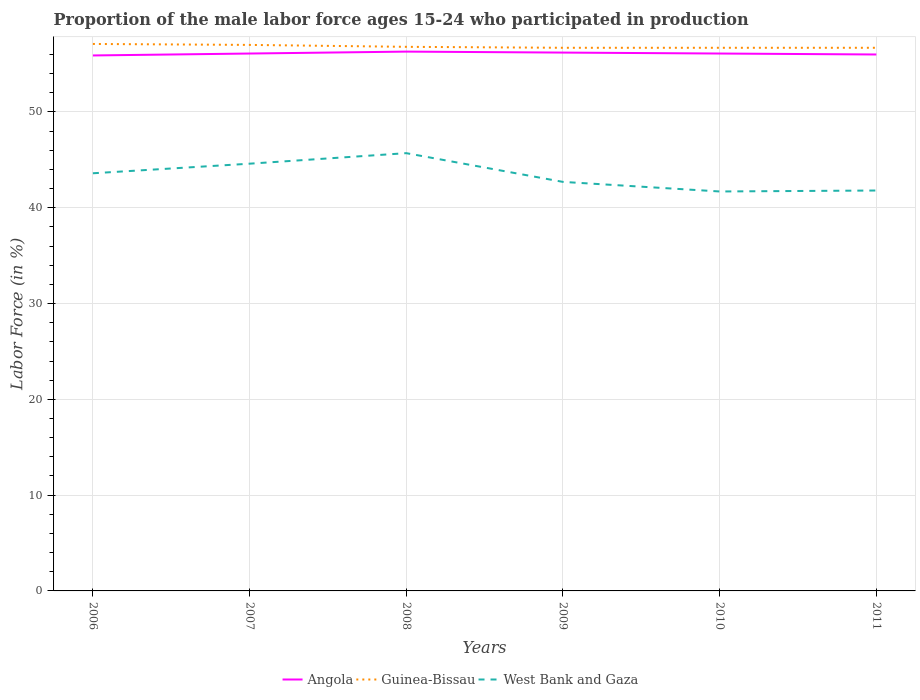Does the line corresponding to Guinea-Bissau intersect with the line corresponding to Angola?
Ensure brevity in your answer.  No. Is the number of lines equal to the number of legend labels?
Offer a very short reply. Yes. Across all years, what is the maximum proportion of the male labor force who participated in production in Guinea-Bissau?
Provide a succinct answer. 56.7. What is the total proportion of the male labor force who participated in production in West Bank and Gaza in the graph?
Give a very brief answer. 0.9. What is the difference between the highest and the second highest proportion of the male labor force who participated in production in West Bank and Gaza?
Offer a terse response. 4. What is the difference between the highest and the lowest proportion of the male labor force who participated in production in Guinea-Bissau?
Offer a terse response. 2. How many years are there in the graph?
Provide a short and direct response. 6. What is the difference between two consecutive major ticks on the Y-axis?
Offer a terse response. 10. Does the graph contain any zero values?
Offer a terse response. No. Where does the legend appear in the graph?
Offer a very short reply. Bottom center. How many legend labels are there?
Your answer should be compact. 3. What is the title of the graph?
Your answer should be very brief. Proportion of the male labor force ages 15-24 who participated in production. Does "Austria" appear as one of the legend labels in the graph?
Your response must be concise. No. What is the label or title of the X-axis?
Keep it short and to the point. Years. What is the label or title of the Y-axis?
Provide a short and direct response. Labor Force (in %). What is the Labor Force (in %) in Angola in 2006?
Your response must be concise. 55.9. What is the Labor Force (in %) of Guinea-Bissau in 2006?
Offer a terse response. 57.1. What is the Labor Force (in %) in West Bank and Gaza in 2006?
Your answer should be compact. 43.6. What is the Labor Force (in %) of Angola in 2007?
Make the answer very short. 56.1. What is the Labor Force (in %) of West Bank and Gaza in 2007?
Your answer should be compact. 44.6. What is the Labor Force (in %) of Angola in 2008?
Your answer should be compact. 56.3. What is the Labor Force (in %) in Guinea-Bissau in 2008?
Ensure brevity in your answer.  56.8. What is the Labor Force (in %) in West Bank and Gaza in 2008?
Your answer should be very brief. 45.7. What is the Labor Force (in %) in Angola in 2009?
Provide a short and direct response. 56.2. What is the Labor Force (in %) of Guinea-Bissau in 2009?
Offer a terse response. 56.7. What is the Labor Force (in %) in West Bank and Gaza in 2009?
Offer a very short reply. 42.7. What is the Labor Force (in %) of Angola in 2010?
Ensure brevity in your answer.  56.1. What is the Labor Force (in %) in Guinea-Bissau in 2010?
Offer a very short reply. 56.7. What is the Labor Force (in %) in West Bank and Gaza in 2010?
Your answer should be compact. 41.7. What is the Labor Force (in %) of Angola in 2011?
Ensure brevity in your answer.  56. What is the Labor Force (in %) of Guinea-Bissau in 2011?
Your answer should be very brief. 56.7. What is the Labor Force (in %) in West Bank and Gaza in 2011?
Your response must be concise. 41.8. Across all years, what is the maximum Labor Force (in %) of Angola?
Offer a very short reply. 56.3. Across all years, what is the maximum Labor Force (in %) in Guinea-Bissau?
Keep it short and to the point. 57.1. Across all years, what is the maximum Labor Force (in %) of West Bank and Gaza?
Your answer should be compact. 45.7. Across all years, what is the minimum Labor Force (in %) in Angola?
Provide a short and direct response. 55.9. Across all years, what is the minimum Labor Force (in %) in Guinea-Bissau?
Ensure brevity in your answer.  56.7. Across all years, what is the minimum Labor Force (in %) in West Bank and Gaza?
Your response must be concise. 41.7. What is the total Labor Force (in %) in Angola in the graph?
Offer a very short reply. 336.6. What is the total Labor Force (in %) of Guinea-Bissau in the graph?
Provide a succinct answer. 341. What is the total Labor Force (in %) of West Bank and Gaza in the graph?
Provide a succinct answer. 260.1. What is the difference between the Labor Force (in %) of Angola in 2006 and that in 2007?
Your answer should be very brief. -0.2. What is the difference between the Labor Force (in %) in Guinea-Bissau in 2006 and that in 2007?
Your response must be concise. 0.1. What is the difference between the Labor Force (in %) of Angola in 2006 and that in 2008?
Make the answer very short. -0.4. What is the difference between the Labor Force (in %) in West Bank and Gaza in 2006 and that in 2008?
Offer a very short reply. -2.1. What is the difference between the Labor Force (in %) in Angola in 2006 and that in 2009?
Offer a very short reply. -0.3. What is the difference between the Labor Force (in %) of Guinea-Bissau in 2006 and that in 2009?
Provide a succinct answer. 0.4. What is the difference between the Labor Force (in %) in Angola in 2006 and that in 2010?
Provide a short and direct response. -0.2. What is the difference between the Labor Force (in %) in Guinea-Bissau in 2006 and that in 2010?
Your answer should be compact. 0.4. What is the difference between the Labor Force (in %) in West Bank and Gaza in 2006 and that in 2010?
Your answer should be very brief. 1.9. What is the difference between the Labor Force (in %) in Angola in 2006 and that in 2011?
Ensure brevity in your answer.  -0.1. What is the difference between the Labor Force (in %) in Guinea-Bissau in 2006 and that in 2011?
Offer a very short reply. 0.4. What is the difference between the Labor Force (in %) of West Bank and Gaza in 2006 and that in 2011?
Give a very brief answer. 1.8. What is the difference between the Labor Force (in %) of Angola in 2007 and that in 2008?
Provide a succinct answer. -0.2. What is the difference between the Labor Force (in %) of Angola in 2007 and that in 2011?
Provide a succinct answer. 0.1. What is the difference between the Labor Force (in %) of Guinea-Bissau in 2008 and that in 2009?
Make the answer very short. 0.1. What is the difference between the Labor Force (in %) of Guinea-Bissau in 2008 and that in 2010?
Keep it short and to the point. 0.1. What is the difference between the Labor Force (in %) of West Bank and Gaza in 2008 and that in 2010?
Keep it short and to the point. 4. What is the difference between the Labor Force (in %) of Angola in 2008 and that in 2011?
Ensure brevity in your answer.  0.3. What is the difference between the Labor Force (in %) of West Bank and Gaza in 2008 and that in 2011?
Give a very brief answer. 3.9. What is the difference between the Labor Force (in %) of West Bank and Gaza in 2009 and that in 2010?
Ensure brevity in your answer.  1. What is the difference between the Labor Force (in %) of Angola in 2009 and that in 2011?
Your response must be concise. 0.2. What is the difference between the Labor Force (in %) in West Bank and Gaza in 2009 and that in 2011?
Your response must be concise. 0.9. What is the difference between the Labor Force (in %) in Guinea-Bissau in 2006 and the Labor Force (in %) in West Bank and Gaza in 2007?
Offer a terse response. 12.5. What is the difference between the Labor Force (in %) in Guinea-Bissau in 2006 and the Labor Force (in %) in West Bank and Gaza in 2008?
Ensure brevity in your answer.  11.4. What is the difference between the Labor Force (in %) in Guinea-Bissau in 2006 and the Labor Force (in %) in West Bank and Gaza in 2009?
Provide a short and direct response. 14.4. What is the difference between the Labor Force (in %) in Angola in 2006 and the Labor Force (in %) in West Bank and Gaza in 2010?
Offer a terse response. 14.2. What is the difference between the Labor Force (in %) of Guinea-Bissau in 2006 and the Labor Force (in %) of West Bank and Gaza in 2010?
Offer a very short reply. 15.4. What is the difference between the Labor Force (in %) in Angola in 2006 and the Labor Force (in %) in West Bank and Gaza in 2011?
Your answer should be compact. 14.1. What is the difference between the Labor Force (in %) in Guinea-Bissau in 2006 and the Labor Force (in %) in West Bank and Gaza in 2011?
Make the answer very short. 15.3. What is the difference between the Labor Force (in %) in Guinea-Bissau in 2007 and the Labor Force (in %) in West Bank and Gaza in 2008?
Ensure brevity in your answer.  11.3. What is the difference between the Labor Force (in %) in Angola in 2007 and the Labor Force (in %) in Guinea-Bissau in 2009?
Your response must be concise. -0.6. What is the difference between the Labor Force (in %) of Guinea-Bissau in 2007 and the Labor Force (in %) of West Bank and Gaza in 2009?
Provide a short and direct response. 14.3. What is the difference between the Labor Force (in %) in Angola in 2007 and the Labor Force (in %) in Guinea-Bissau in 2010?
Your answer should be compact. -0.6. What is the difference between the Labor Force (in %) of Angola in 2007 and the Labor Force (in %) of West Bank and Gaza in 2010?
Give a very brief answer. 14.4. What is the difference between the Labor Force (in %) of Angola in 2007 and the Labor Force (in %) of West Bank and Gaza in 2011?
Your response must be concise. 14.3. What is the difference between the Labor Force (in %) in Angola in 2008 and the Labor Force (in %) in Guinea-Bissau in 2009?
Give a very brief answer. -0.4. What is the difference between the Labor Force (in %) in Guinea-Bissau in 2008 and the Labor Force (in %) in West Bank and Gaza in 2009?
Give a very brief answer. 14.1. What is the difference between the Labor Force (in %) in Angola in 2008 and the Labor Force (in %) in West Bank and Gaza in 2010?
Provide a short and direct response. 14.6. What is the difference between the Labor Force (in %) in Guinea-Bissau in 2008 and the Labor Force (in %) in West Bank and Gaza in 2010?
Make the answer very short. 15.1. What is the difference between the Labor Force (in %) in Angola in 2008 and the Labor Force (in %) in Guinea-Bissau in 2011?
Offer a very short reply. -0.4. What is the difference between the Labor Force (in %) in Angola in 2008 and the Labor Force (in %) in West Bank and Gaza in 2011?
Give a very brief answer. 14.5. What is the difference between the Labor Force (in %) in Guinea-Bissau in 2008 and the Labor Force (in %) in West Bank and Gaza in 2011?
Offer a very short reply. 15. What is the difference between the Labor Force (in %) in Angola in 2009 and the Labor Force (in %) in West Bank and Gaza in 2010?
Make the answer very short. 14.5. What is the difference between the Labor Force (in %) of Angola in 2009 and the Labor Force (in %) of Guinea-Bissau in 2011?
Provide a succinct answer. -0.5. What is the difference between the Labor Force (in %) of Angola in 2009 and the Labor Force (in %) of West Bank and Gaza in 2011?
Offer a terse response. 14.4. What is the difference between the Labor Force (in %) in Angola in 2010 and the Labor Force (in %) in West Bank and Gaza in 2011?
Offer a terse response. 14.3. What is the average Labor Force (in %) in Angola per year?
Your answer should be compact. 56.1. What is the average Labor Force (in %) in Guinea-Bissau per year?
Give a very brief answer. 56.83. What is the average Labor Force (in %) in West Bank and Gaza per year?
Ensure brevity in your answer.  43.35. In the year 2006, what is the difference between the Labor Force (in %) of Angola and Labor Force (in %) of Guinea-Bissau?
Your answer should be very brief. -1.2. In the year 2006, what is the difference between the Labor Force (in %) of Guinea-Bissau and Labor Force (in %) of West Bank and Gaza?
Your response must be concise. 13.5. In the year 2007, what is the difference between the Labor Force (in %) in Angola and Labor Force (in %) in Guinea-Bissau?
Give a very brief answer. -0.9. In the year 2008, what is the difference between the Labor Force (in %) of Angola and Labor Force (in %) of Guinea-Bissau?
Your answer should be compact. -0.5. In the year 2008, what is the difference between the Labor Force (in %) in Guinea-Bissau and Labor Force (in %) in West Bank and Gaza?
Your response must be concise. 11.1. In the year 2009, what is the difference between the Labor Force (in %) in Angola and Labor Force (in %) in West Bank and Gaza?
Keep it short and to the point. 13.5. In the year 2009, what is the difference between the Labor Force (in %) of Guinea-Bissau and Labor Force (in %) of West Bank and Gaza?
Offer a very short reply. 14. In the year 2011, what is the difference between the Labor Force (in %) in Angola and Labor Force (in %) in Guinea-Bissau?
Ensure brevity in your answer.  -0.7. In the year 2011, what is the difference between the Labor Force (in %) in Angola and Labor Force (in %) in West Bank and Gaza?
Provide a succinct answer. 14.2. In the year 2011, what is the difference between the Labor Force (in %) in Guinea-Bissau and Labor Force (in %) in West Bank and Gaza?
Ensure brevity in your answer.  14.9. What is the ratio of the Labor Force (in %) of Angola in 2006 to that in 2007?
Give a very brief answer. 1. What is the ratio of the Labor Force (in %) of West Bank and Gaza in 2006 to that in 2007?
Provide a succinct answer. 0.98. What is the ratio of the Labor Force (in %) in Angola in 2006 to that in 2008?
Make the answer very short. 0.99. What is the ratio of the Labor Force (in %) of Guinea-Bissau in 2006 to that in 2008?
Offer a terse response. 1.01. What is the ratio of the Labor Force (in %) in West Bank and Gaza in 2006 to that in 2008?
Provide a short and direct response. 0.95. What is the ratio of the Labor Force (in %) in Angola in 2006 to that in 2009?
Your response must be concise. 0.99. What is the ratio of the Labor Force (in %) of Guinea-Bissau in 2006 to that in 2009?
Your response must be concise. 1.01. What is the ratio of the Labor Force (in %) in West Bank and Gaza in 2006 to that in 2009?
Your answer should be very brief. 1.02. What is the ratio of the Labor Force (in %) of Angola in 2006 to that in 2010?
Provide a short and direct response. 1. What is the ratio of the Labor Force (in %) in Guinea-Bissau in 2006 to that in 2010?
Give a very brief answer. 1.01. What is the ratio of the Labor Force (in %) in West Bank and Gaza in 2006 to that in 2010?
Your answer should be very brief. 1.05. What is the ratio of the Labor Force (in %) in Angola in 2006 to that in 2011?
Give a very brief answer. 1. What is the ratio of the Labor Force (in %) in Guinea-Bissau in 2006 to that in 2011?
Give a very brief answer. 1.01. What is the ratio of the Labor Force (in %) in West Bank and Gaza in 2006 to that in 2011?
Your answer should be compact. 1.04. What is the ratio of the Labor Force (in %) of Guinea-Bissau in 2007 to that in 2008?
Offer a very short reply. 1. What is the ratio of the Labor Force (in %) of West Bank and Gaza in 2007 to that in 2008?
Ensure brevity in your answer.  0.98. What is the ratio of the Labor Force (in %) in Angola in 2007 to that in 2009?
Keep it short and to the point. 1. What is the ratio of the Labor Force (in %) in West Bank and Gaza in 2007 to that in 2009?
Your answer should be compact. 1.04. What is the ratio of the Labor Force (in %) of Angola in 2007 to that in 2010?
Offer a very short reply. 1. What is the ratio of the Labor Force (in %) of Guinea-Bissau in 2007 to that in 2010?
Offer a terse response. 1.01. What is the ratio of the Labor Force (in %) of West Bank and Gaza in 2007 to that in 2010?
Offer a very short reply. 1.07. What is the ratio of the Labor Force (in %) in West Bank and Gaza in 2007 to that in 2011?
Provide a succinct answer. 1.07. What is the ratio of the Labor Force (in %) in Angola in 2008 to that in 2009?
Your answer should be compact. 1. What is the ratio of the Labor Force (in %) in Guinea-Bissau in 2008 to that in 2009?
Your answer should be compact. 1. What is the ratio of the Labor Force (in %) of West Bank and Gaza in 2008 to that in 2009?
Make the answer very short. 1.07. What is the ratio of the Labor Force (in %) of Angola in 2008 to that in 2010?
Make the answer very short. 1. What is the ratio of the Labor Force (in %) in West Bank and Gaza in 2008 to that in 2010?
Your answer should be very brief. 1.1. What is the ratio of the Labor Force (in %) of Angola in 2008 to that in 2011?
Provide a succinct answer. 1.01. What is the ratio of the Labor Force (in %) in Guinea-Bissau in 2008 to that in 2011?
Ensure brevity in your answer.  1. What is the ratio of the Labor Force (in %) in West Bank and Gaza in 2008 to that in 2011?
Give a very brief answer. 1.09. What is the ratio of the Labor Force (in %) of Angola in 2009 to that in 2010?
Provide a succinct answer. 1. What is the ratio of the Labor Force (in %) in Guinea-Bissau in 2009 to that in 2010?
Offer a very short reply. 1. What is the ratio of the Labor Force (in %) in West Bank and Gaza in 2009 to that in 2011?
Give a very brief answer. 1.02. What is the ratio of the Labor Force (in %) of Guinea-Bissau in 2010 to that in 2011?
Ensure brevity in your answer.  1. What is the ratio of the Labor Force (in %) of West Bank and Gaza in 2010 to that in 2011?
Provide a short and direct response. 1. What is the difference between the highest and the second highest Labor Force (in %) in Angola?
Offer a very short reply. 0.1. What is the difference between the highest and the second highest Labor Force (in %) in Guinea-Bissau?
Provide a succinct answer. 0.1. What is the difference between the highest and the lowest Labor Force (in %) of Angola?
Provide a succinct answer. 0.4. What is the difference between the highest and the lowest Labor Force (in %) of Guinea-Bissau?
Your answer should be compact. 0.4. 